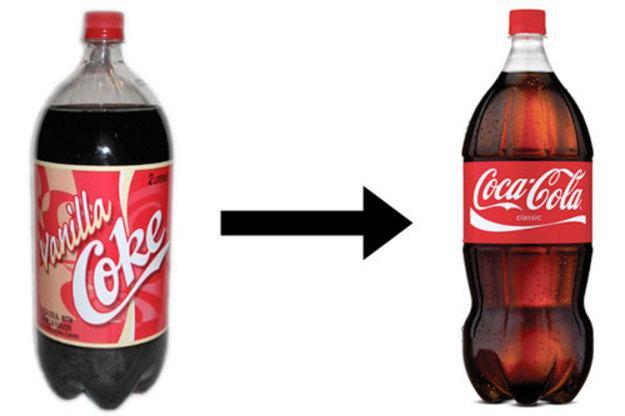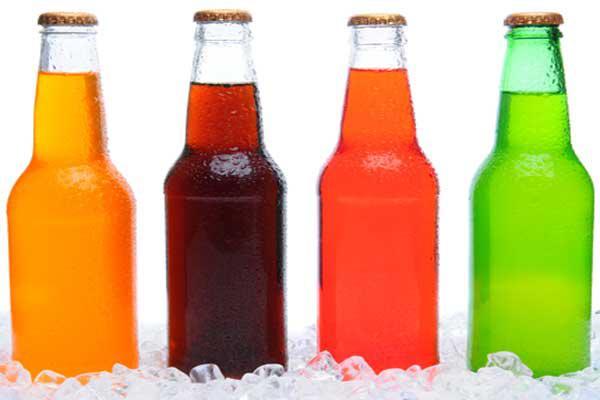The first image is the image on the left, the second image is the image on the right. For the images shown, is this caption "Exactly three bottles of fizzy drink can be seen in each image." true? Answer yes or no. No. The first image is the image on the left, the second image is the image on the right. Considering the images on both sides, is "The left image shows exactly three bottles of different colored liquids with no labels, and the right image shows three soda bottles with printed labels on the front." valid? Answer yes or no. No. 